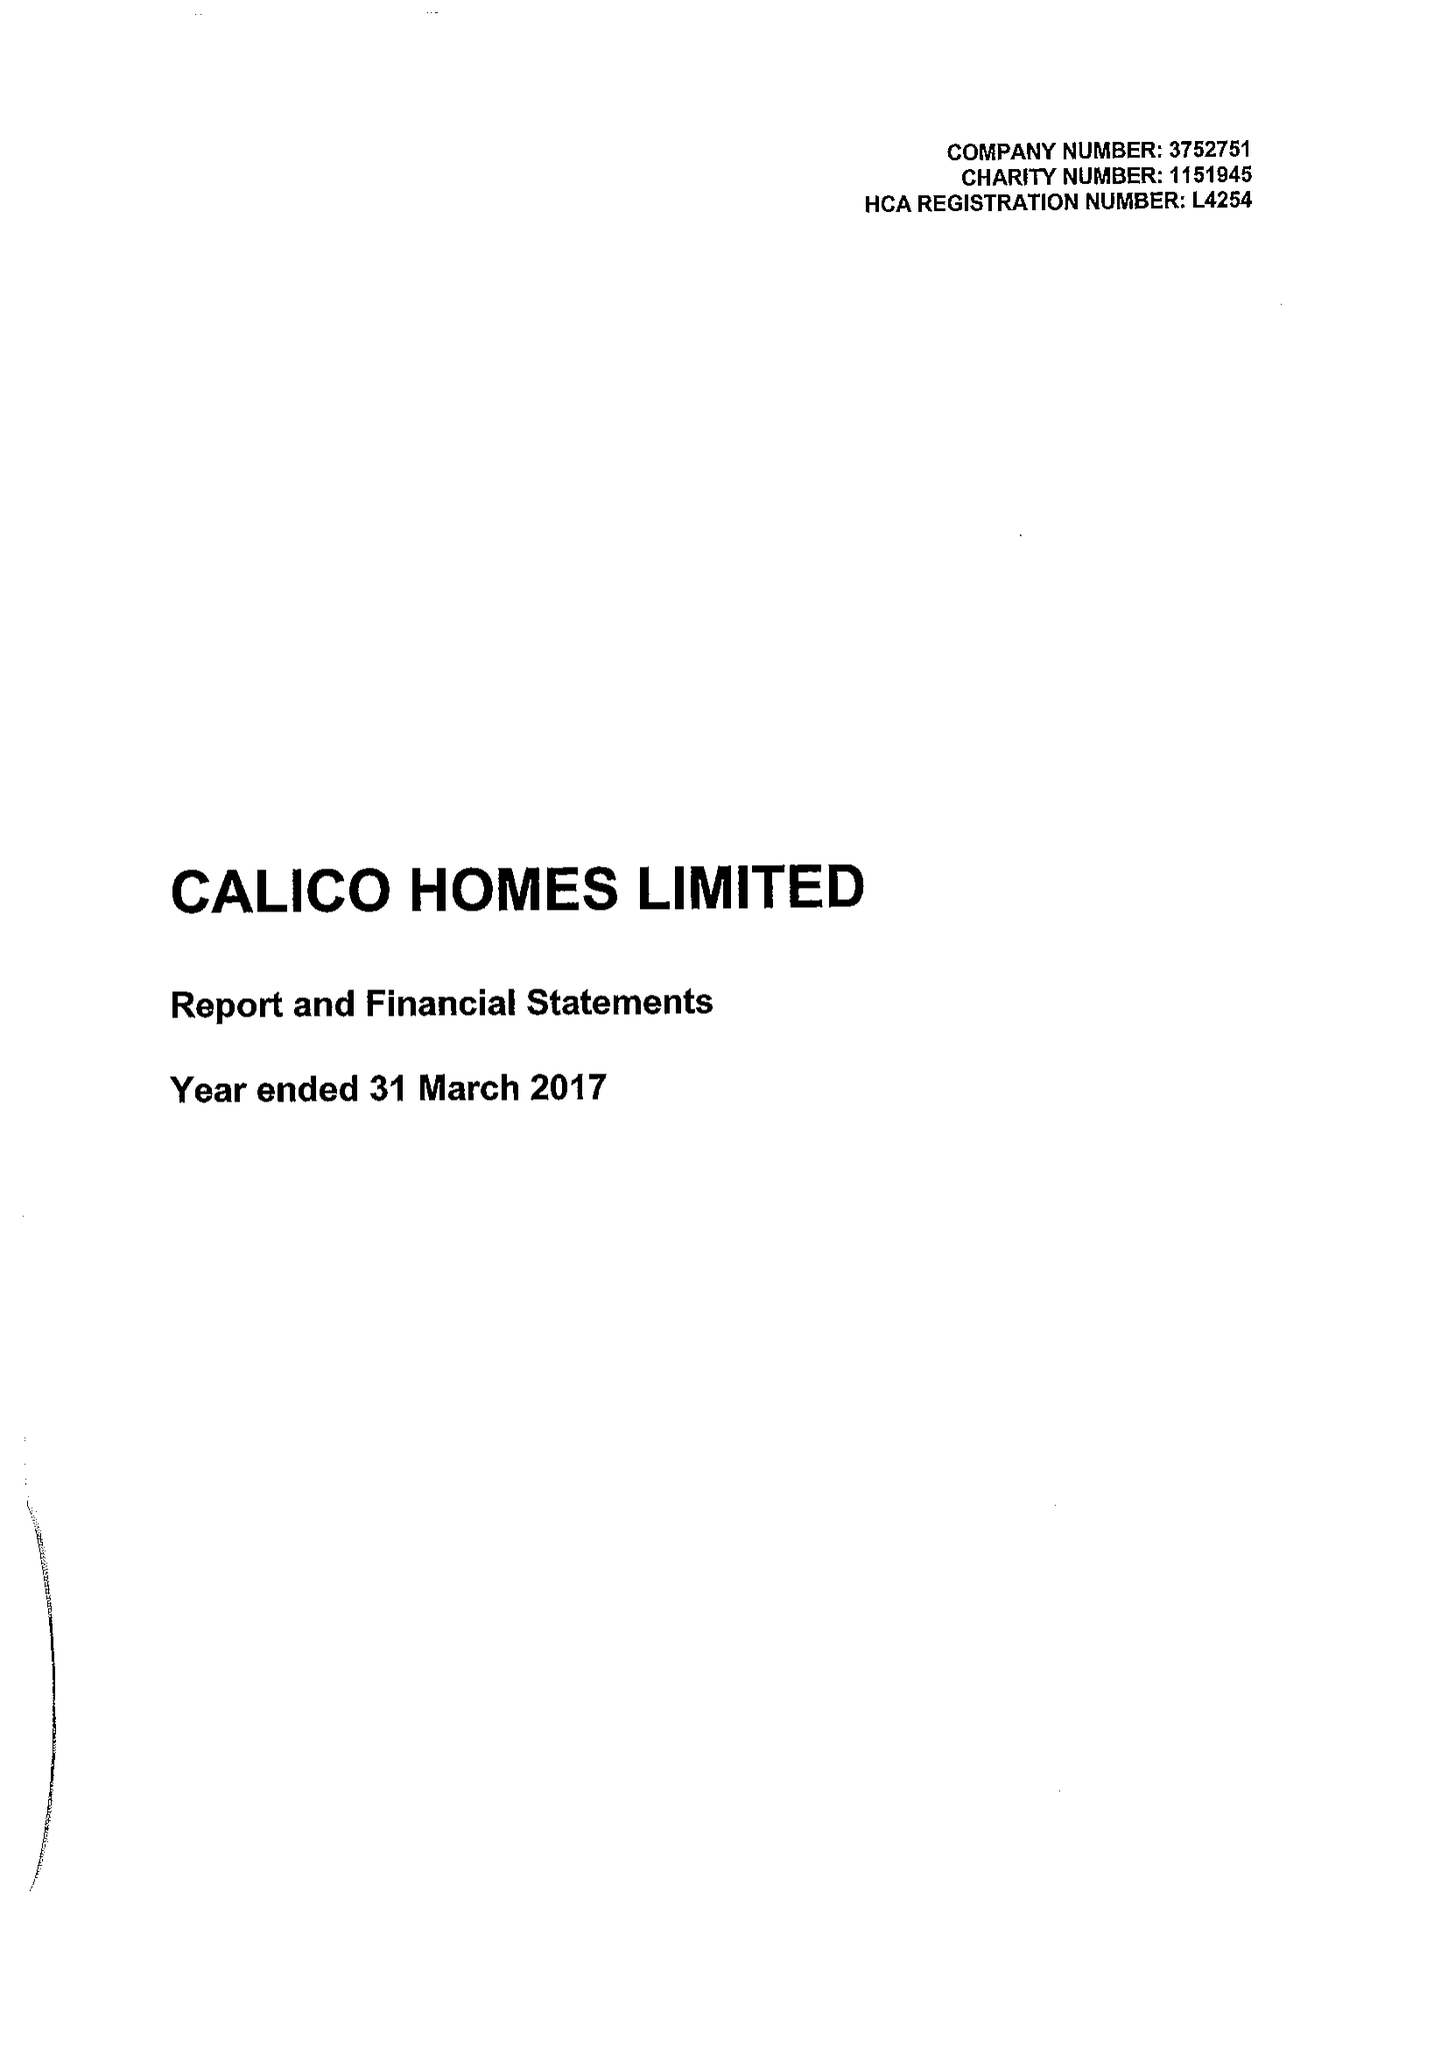What is the value for the income_annually_in_british_pounds?
Answer the question using a single word or phrase. 23502000.00 